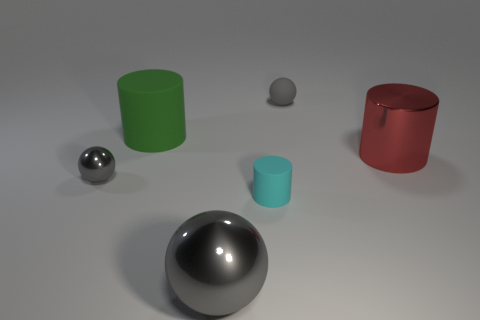Add 3 small brown blocks. How many objects exist? 9 Subtract 0 cyan blocks. How many objects are left? 6 Subtract all big metal things. Subtract all small cyan cylinders. How many objects are left? 3 Add 5 big matte objects. How many big matte objects are left? 6 Add 2 big green cylinders. How many big green cylinders exist? 3 